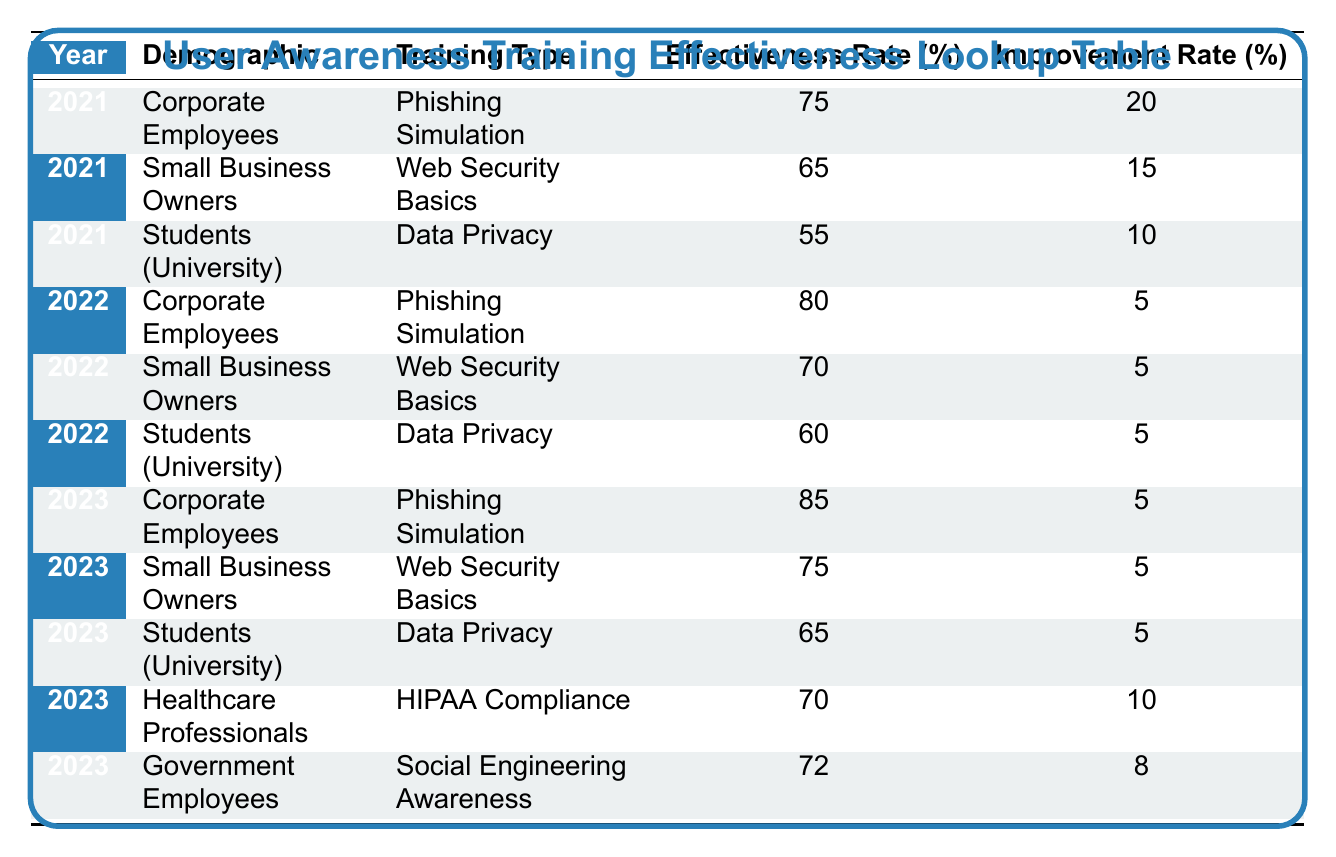What was the effectiveness rate for Corporate Employees in 2022? The table shows that in 2022, the effectiveness rate for Corporate Employees participating in Phishing Simulation training was 80%.
Answer: 80% Which demographic had the lowest improvement rate in 2021? Looking at the improvement rates for 2021, Corporate Employees had 20%, Small Business Owners had 15%, and Students (University) had 10%. The lowest improvement rate is thus 10% for Students (University).
Answer: 10% What is the average effectiveness rate for Small Business Owners across all years? The effectiveness rates for Small Business Owners are 65% (2021), 70% (2022), and 75% (2023). The sum is 65 + 70 + 75 = 210. Dividing by 3 gives an average of 210/3 = 70%.
Answer: 70% Did the effectiveness rate for Students (University) improve from 2021 to 2022? In 2021, the effectiveness rate for Students (University) was 55%, and in 2022, it was 60%. Since 60% is greater than 55%, the rate did improve.
Answer: Yes Which training type had the highest effectiveness rate in 2023? In 2023, the effectiveness rates were 85% for Phishing Simulation (Corporate Employees), 75% for Web Security Basics (Small Business Owners), 65% for Data Privacy (Students), 70% for HIPAA Compliance (Healthcare Professionals), and 72% for Social Engineering Awareness (Government Employees). The highest rate is 85% for Phishing Simulation.
Answer: 85% 